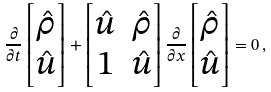Convert formula to latex. <formula><loc_0><loc_0><loc_500><loc_500>\frac { \partial } { \partial t } \begin{bmatrix} \hat { \rho } \\ \hat { u } \end{bmatrix} + \begin{bmatrix} \hat { u } & \hat { \rho } \\ 1 & \hat { u } \end{bmatrix} \frac { \partial } { \partial x } \begin{bmatrix} \hat { \rho } \\ \hat { u } \end{bmatrix} = 0 \, ,</formula> 